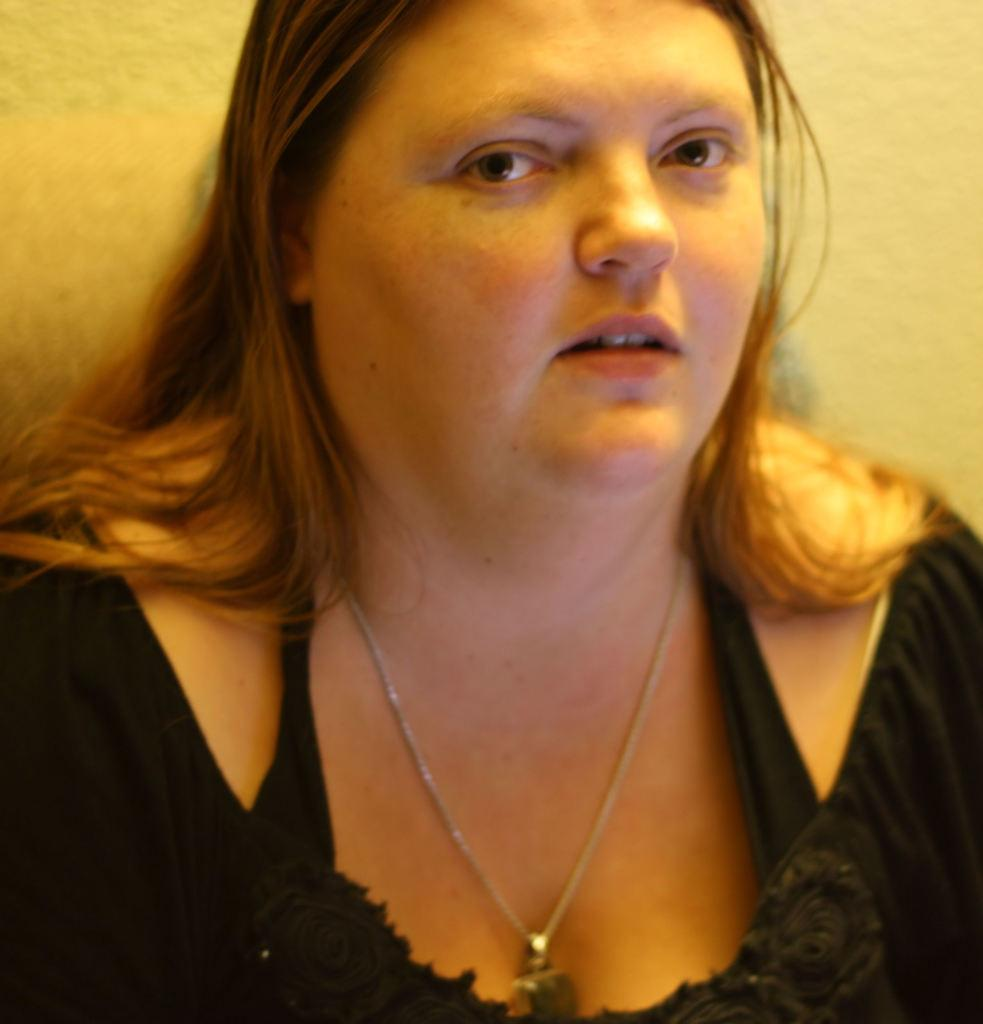Who is the main subject in the foreground of the image? There is a woman in the foreground of the image. What is the woman wearing in the image? The woman is wearing a black dress. What can be seen in the background of the image? There is a wall in the background of the image. What type of effect does the yak have on the woman's skirt in the image? There is no yak or skirt present in the image, so this question cannot be answered. 